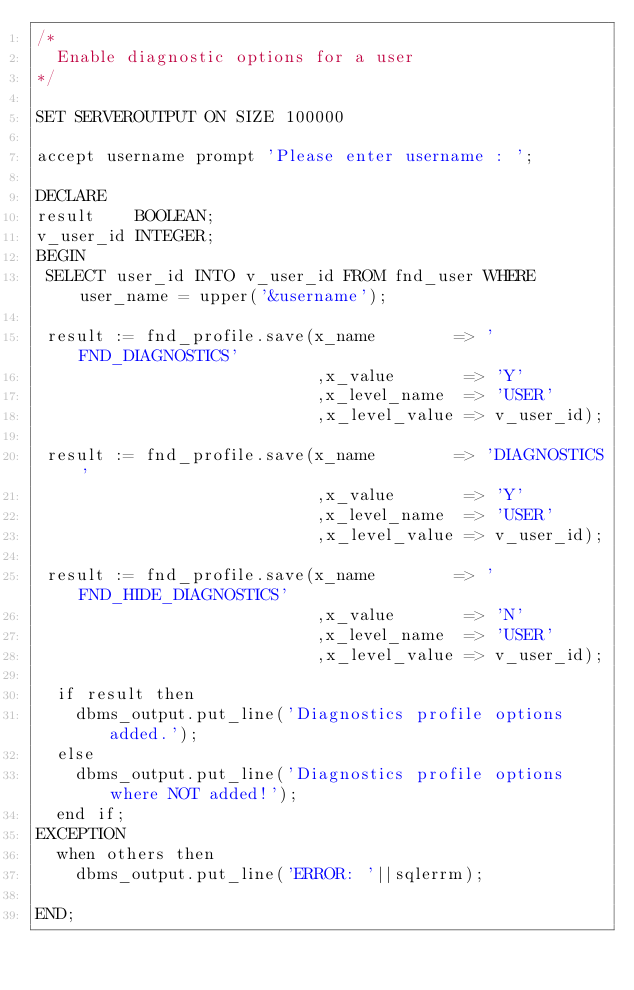<code> <loc_0><loc_0><loc_500><loc_500><_SQL_>/*
  Enable diagnostic options for a user
*/

SET SERVEROUTPUT ON SIZE 100000

accept username prompt 'Please enter username : ';

DECLARE
result    BOOLEAN;
v_user_id INTEGER;
BEGIN
 SELECT user_id INTO v_user_id FROM fnd_user WHERE user_name = upper('&username');

 result := fnd_profile.save(x_name        => 'FND_DIAGNOSTICS'
                            ,x_value       => 'Y'
                            ,x_level_name  => 'USER'
                            ,x_level_value => v_user_id);

 result := fnd_profile.save(x_name        => 'DIAGNOSTICS'
                            ,x_value       => 'Y'
                            ,x_level_name  => 'USER'
                            ,x_level_value => v_user_id);

 result := fnd_profile.save(x_name        => 'FND_HIDE_DIAGNOSTICS'
                            ,x_value       => 'N'
                            ,x_level_name  => 'USER'
                            ,x_level_value => v_user_id);

  if result then
    dbms_output.put_line('Diagnostics profile options added.');
  else
    dbms_output.put_line('Diagnostics profile options where NOT added!');
  end if;
EXCEPTION
  when others then
    dbms_output.put_line('ERROR: '||sqlerrm);

END;
</code> 